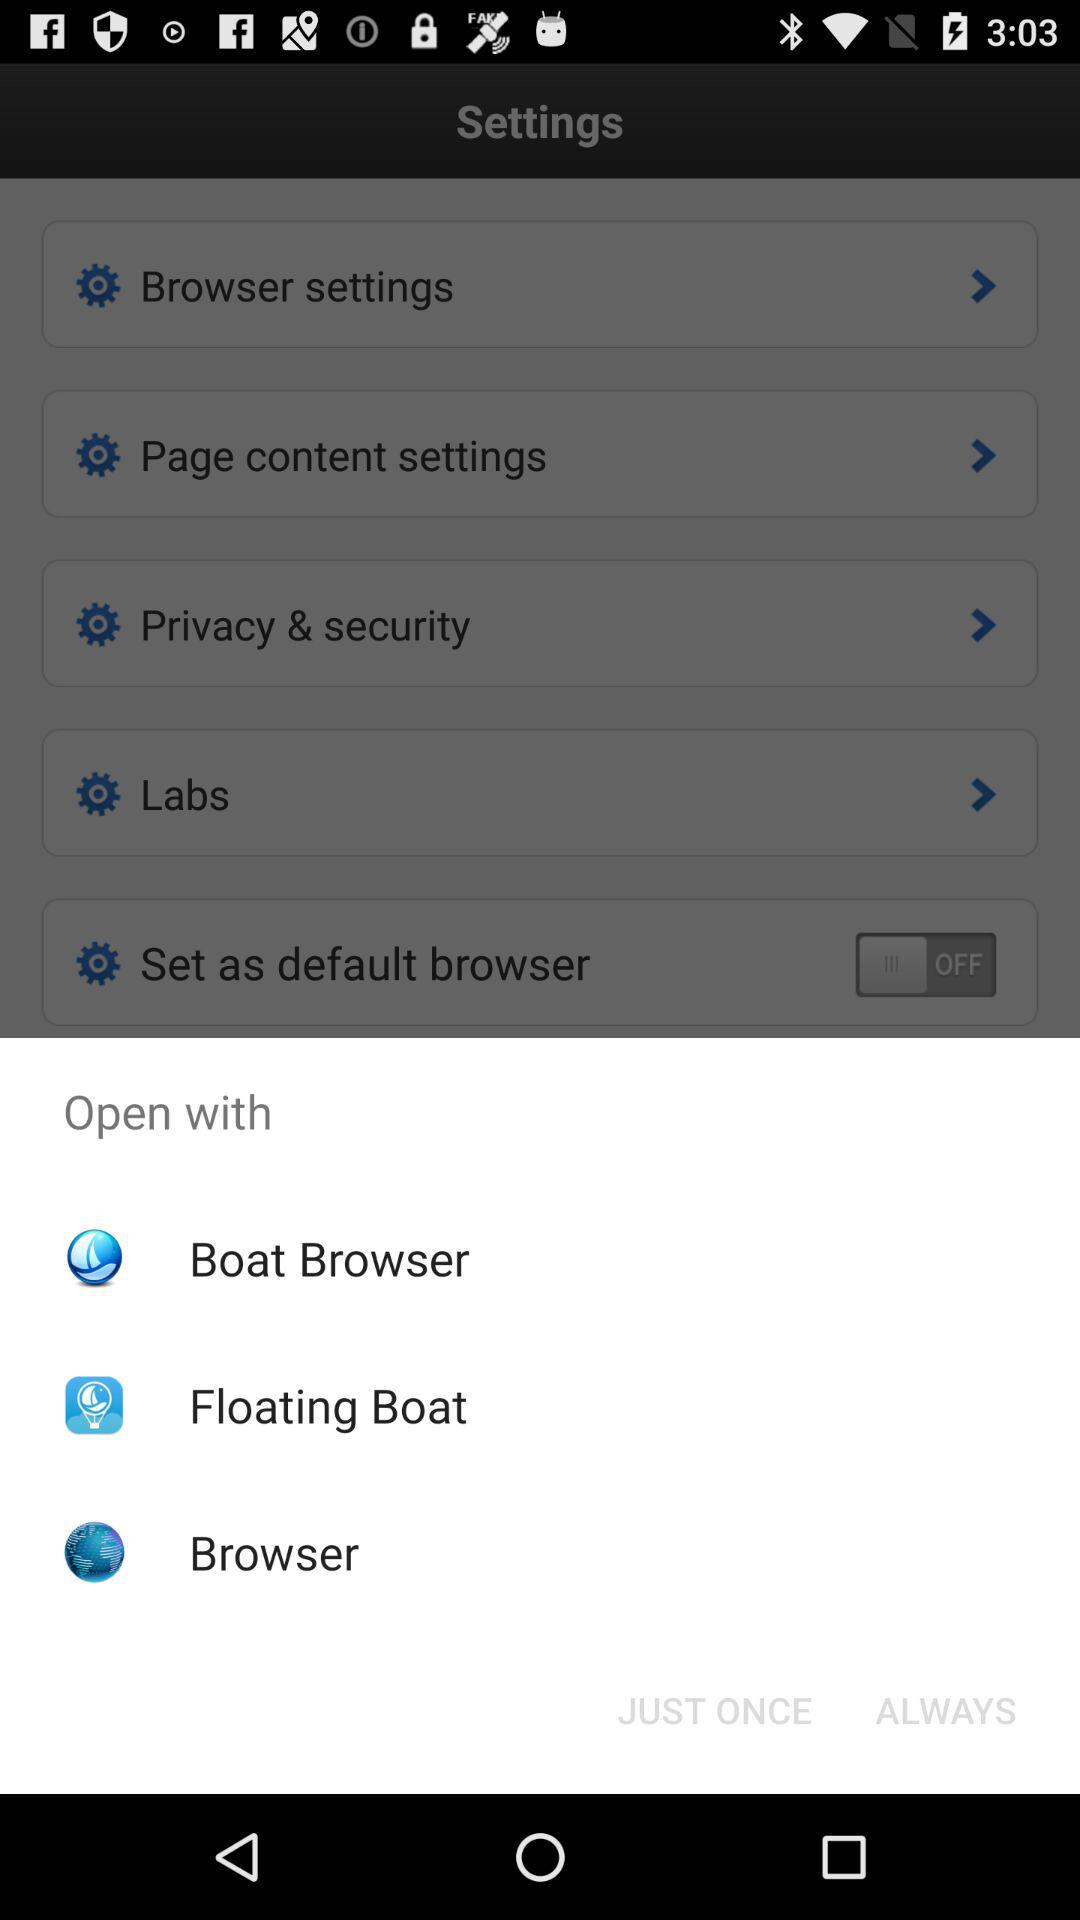How many options are there for opening a link?
Answer the question using a single word or phrase. 3 